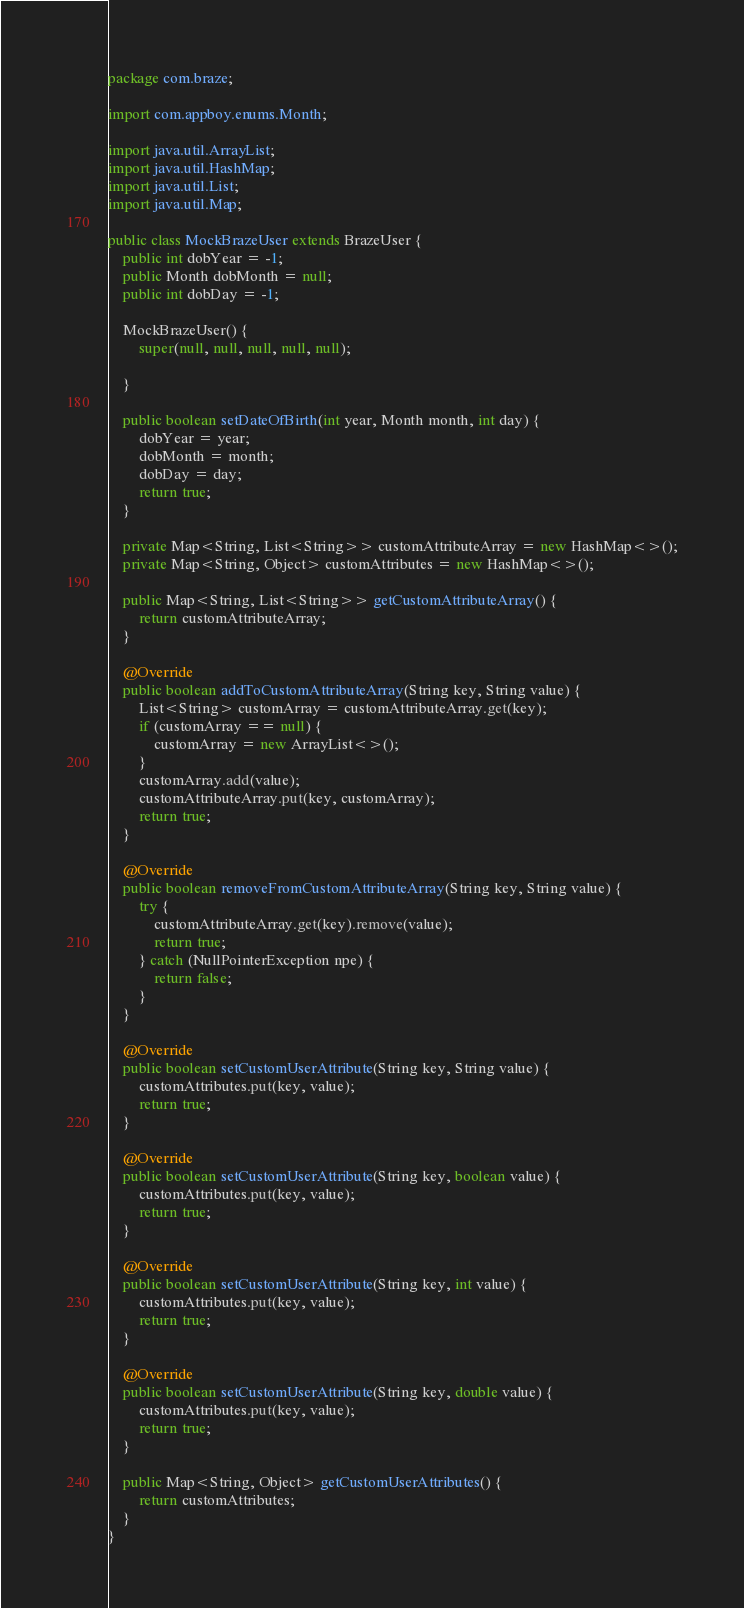<code> <loc_0><loc_0><loc_500><loc_500><_Java_>package com.braze;

import com.appboy.enums.Month;

import java.util.ArrayList;
import java.util.HashMap;
import java.util.List;
import java.util.Map;

public class MockBrazeUser extends BrazeUser {
    public int dobYear = -1;
    public Month dobMonth = null;
    public int dobDay = -1;

    MockBrazeUser() {
        super(null, null, null, null, null);

    }

    public boolean setDateOfBirth(int year, Month month, int day) {
        dobYear = year;
        dobMonth = month;
        dobDay = day;
        return true;
    }

    private Map<String, List<String>> customAttributeArray = new HashMap<>();
    private Map<String, Object> customAttributes = new HashMap<>();

    public Map<String, List<String>> getCustomAttributeArray() {
        return customAttributeArray;
    }

    @Override
    public boolean addToCustomAttributeArray(String key, String value) {
        List<String> customArray = customAttributeArray.get(key);
        if (customArray == null) {
            customArray = new ArrayList<>();
        }
        customArray.add(value);
        customAttributeArray.put(key, customArray);
        return true;
    }

    @Override
    public boolean removeFromCustomAttributeArray(String key, String value) {
        try {
            customAttributeArray.get(key).remove(value);
            return true;
        } catch (NullPointerException npe) {
            return false;
        }
    }

    @Override
    public boolean setCustomUserAttribute(String key, String value) {
        customAttributes.put(key, value);
        return true;
    }

    @Override
    public boolean setCustomUserAttribute(String key, boolean value) {
        customAttributes.put(key, value);
        return true;
    }

    @Override
    public boolean setCustomUserAttribute(String key, int value) {
        customAttributes.put(key, value);
        return true;
    }

    @Override
    public boolean setCustomUserAttribute(String key, double value) {
        customAttributes.put(key, value);
        return true;
    }

    public Map<String, Object> getCustomUserAttributes() {
        return customAttributes;
    }
}
</code> 